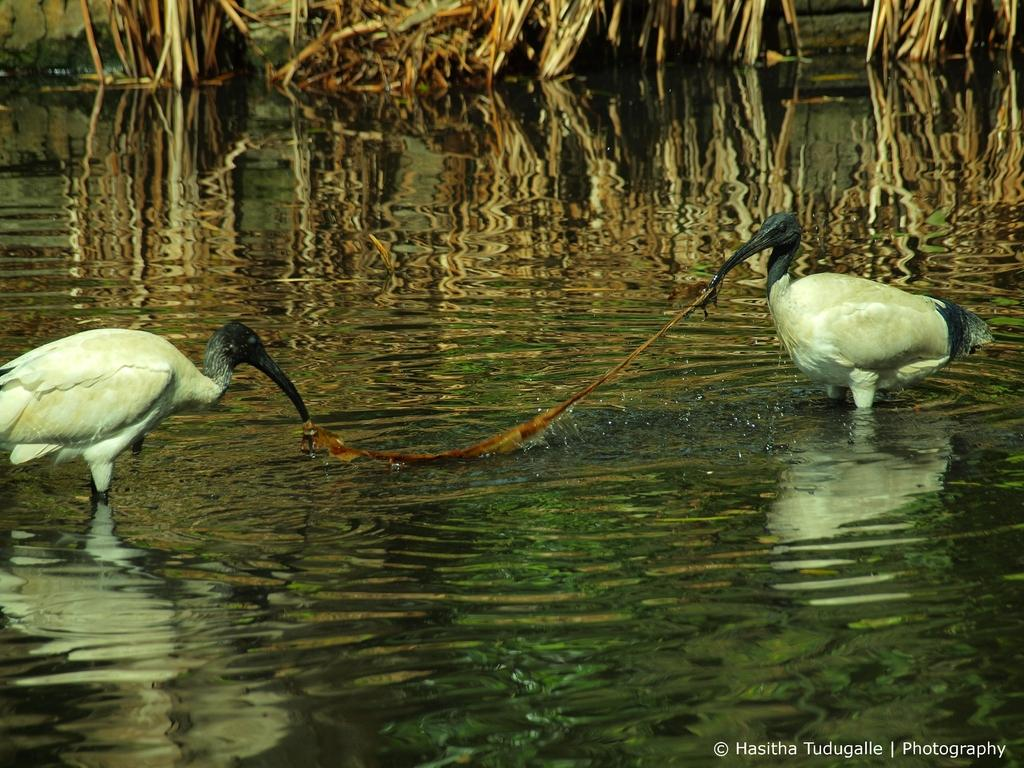How many birds are in the image? There are two birds in the image. Where are the birds located in the image? The birds are standing in the water. What type of vegetation can be seen at the top of the image? There is dried grass visible at the top of the image. Is there any text or marking at the bottom right side of the image? Yes, there is a watermark at the bottom right side of the image. What type of ink is being used by the goldfish in the image? There are no goldfish present in the image; it features two birds standing in the water. What note is the bird singing in the image? The image does not depict the birds singing, so it is not possible to determine the note they might be singing. 